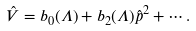Convert formula to latex. <formula><loc_0><loc_0><loc_500><loc_500>\hat { V } = b _ { 0 } ( \Lambda ) + b _ { 2 } ( \Lambda ) \hat { p } ^ { 2 } + \cdots .</formula> 